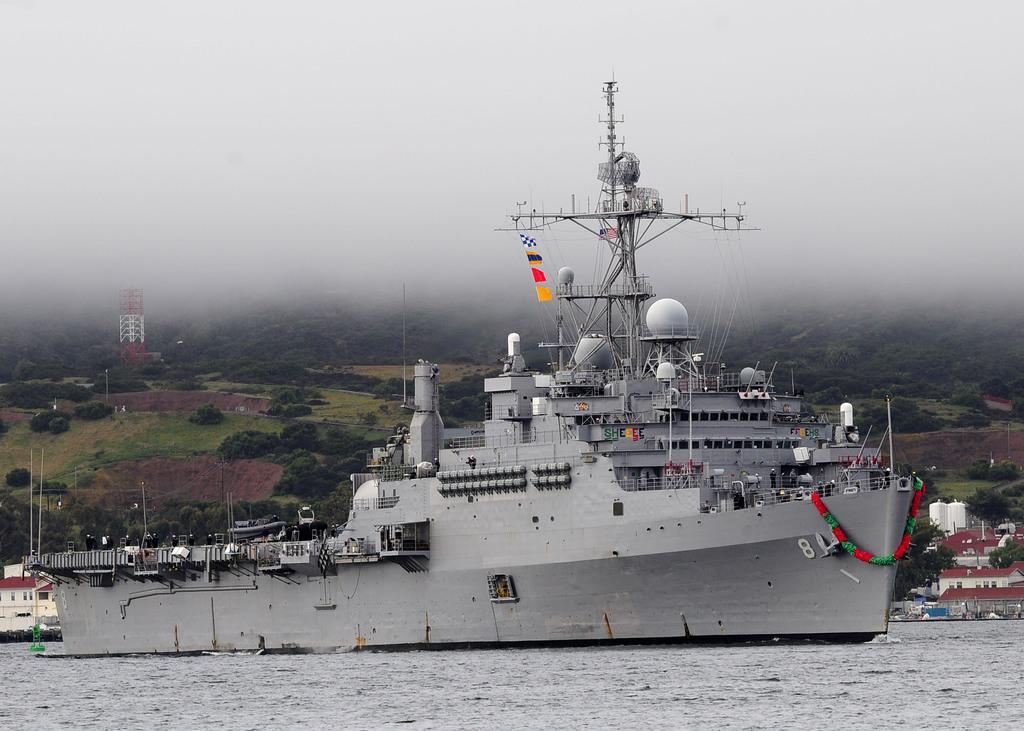In one or two sentences, can you explain what this image depicts? In this image we can see the mountains, one big boat on the lake, some flags attached to the boat, some houses, some poles, some objects are on the boat, one tower, some trees, bushes, plants and grass on the surface. At the top there is the sky. 